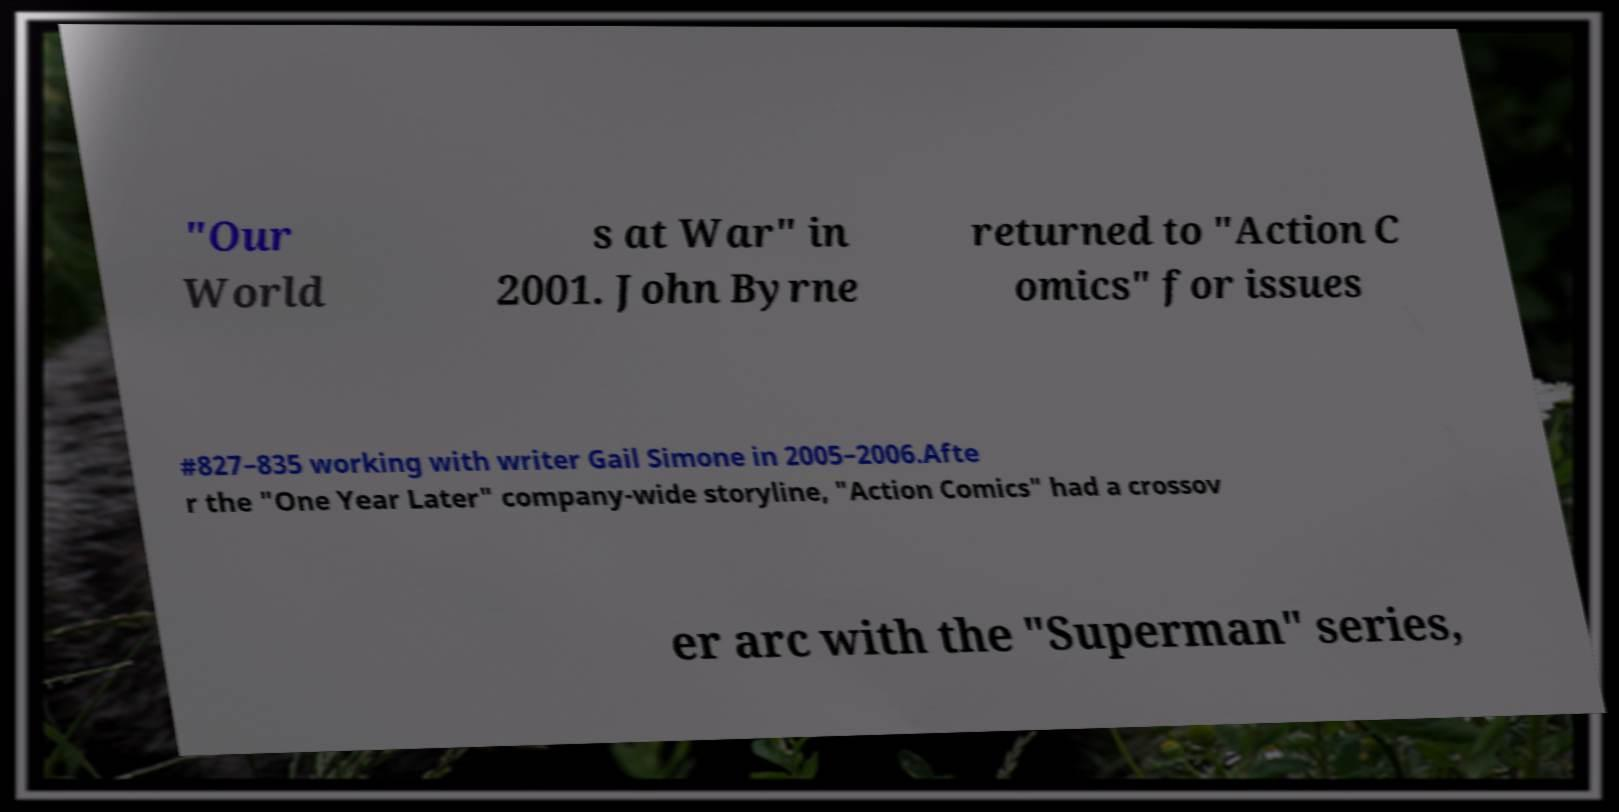I need the written content from this picture converted into text. Can you do that? "Our World s at War" in 2001. John Byrne returned to "Action C omics" for issues #827–835 working with writer Gail Simone in 2005–2006.Afte r the "One Year Later" company-wide storyline, "Action Comics" had a crossov er arc with the "Superman" series, 